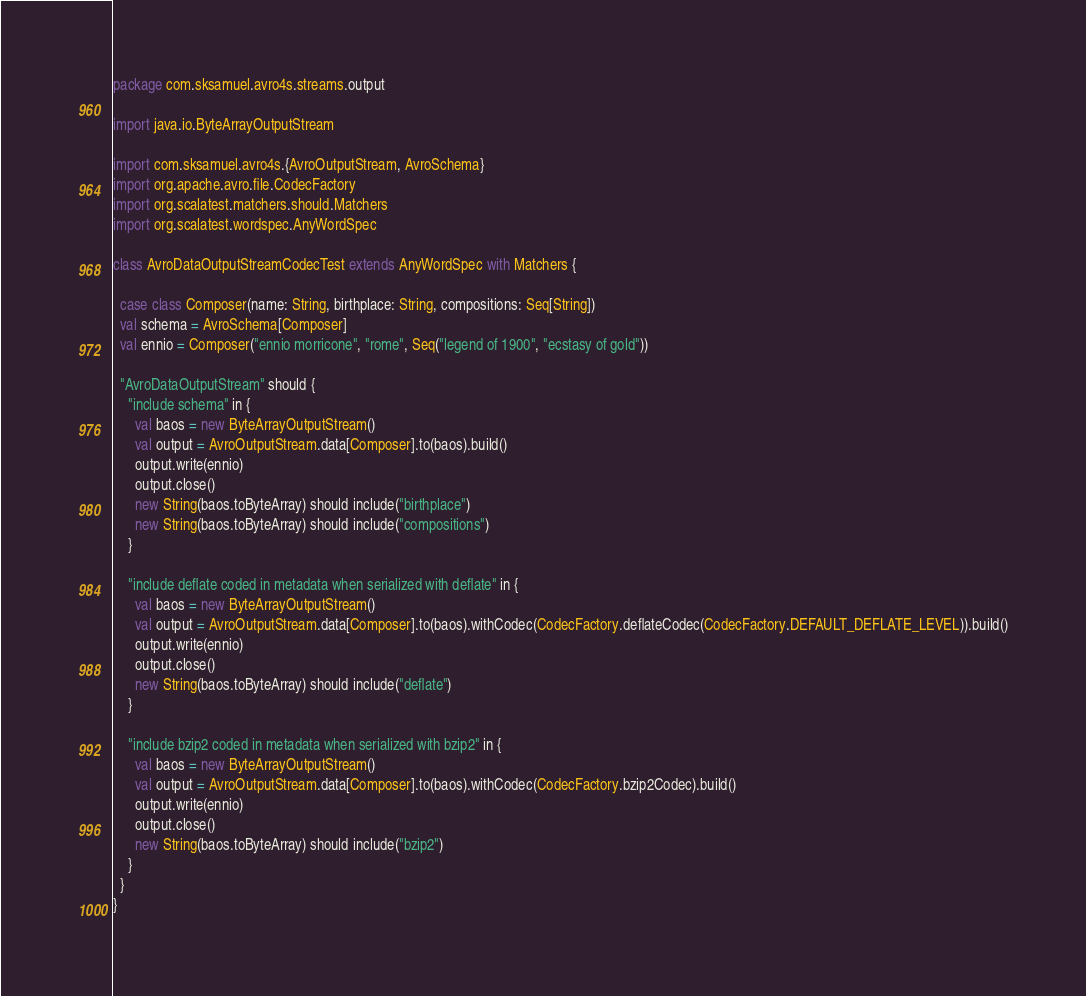<code> <loc_0><loc_0><loc_500><loc_500><_Scala_>package com.sksamuel.avro4s.streams.output

import java.io.ByteArrayOutputStream

import com.sksamuel.avro4s.{AvroOutputStream, AvroSchema}
import org.apache.avro.file.CodecFactory
import org.scalatest.matchers.should.Matchers
import org.scalatest.wordspec.AnyWordSpec

class AvroDataOutputStreamCodecTest extends AnyWordSpec with Matchers {

  case class Composer(name: String, birthplace: String, compositions: Seq[String])
  val schema = AvroSchema[Composer]
  val ennio = Composer("ennio morricone", "rome", Seq("legend of 1900", "ecstasy of gold"))

  "AvroDataOutputStream" should {
    "include schema" in {
      val baos = new ByteArrayOutputStream()
      val output = AvroOutputStream.data[Composer].to(baos).build()
      output.write(ennio)
      output.close()
      new String(baos.toByteArray) should include("birthplace")
      new String(baos.toByteArray) should include("compositions")
    }

    "include deflate coded in metadata when serialized with deflate" in {
      val baos = new ByteArrayOutputStream()
      val output = AvroOutputStream.data[Composer].to(baos).withCodec(CodecFactory.deflateCodec(CodecFactory.DEFAULT_DEFLATE_LEVEL)).build()
      output.write(ennio)
      output.close()
      new String(baos.toByteArray) should include("deflate")
    }

    "include bzip2 coded in metadata when serialized with bzip2" in {
      val baos = new ByteArrayOutputStream()
      val output = AvroOutputStream.data[Composer].to(baos).withCodec(CodecFactory.bzip2Codec).build()
      output.write(ennio)
      output.close()
      new String(baos.toByteArray) should include("bzip2")
    }
  }
}
</code> 